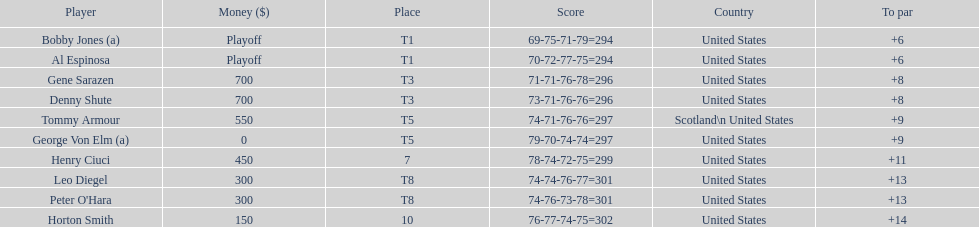Gene sarazen and denny shute both originate from which nation? United States. 